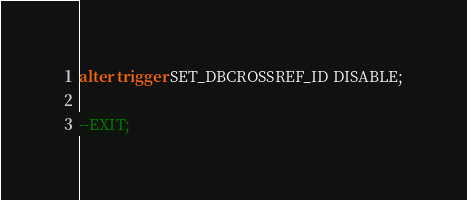<code> <loc_0><loc_0><loc_500><loc_500><_SQL_>
alter trigger SET_DBCROSSREF_ID DISABLE;

--EXIT;
</code> 